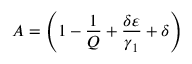Convert formula to latex. <formula><loc_0><loc_0><loc_500><loc_500>A = \left ( 1 - \frac { 1 } { Q } + \frac { \delta \varepsilon } { \gamma _ { 1 } } + \delta \right )</formula> 